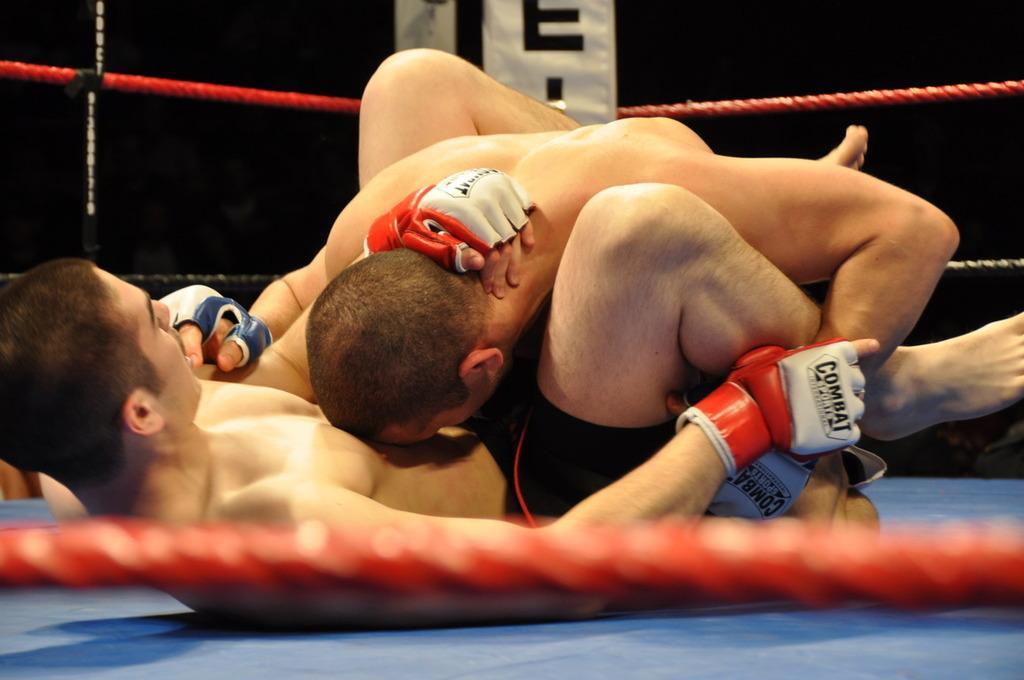In one or two sentences, can you explain what this image depicts? In this picture I can observe two men fighting inside the wrestling ring. The background is dark. 